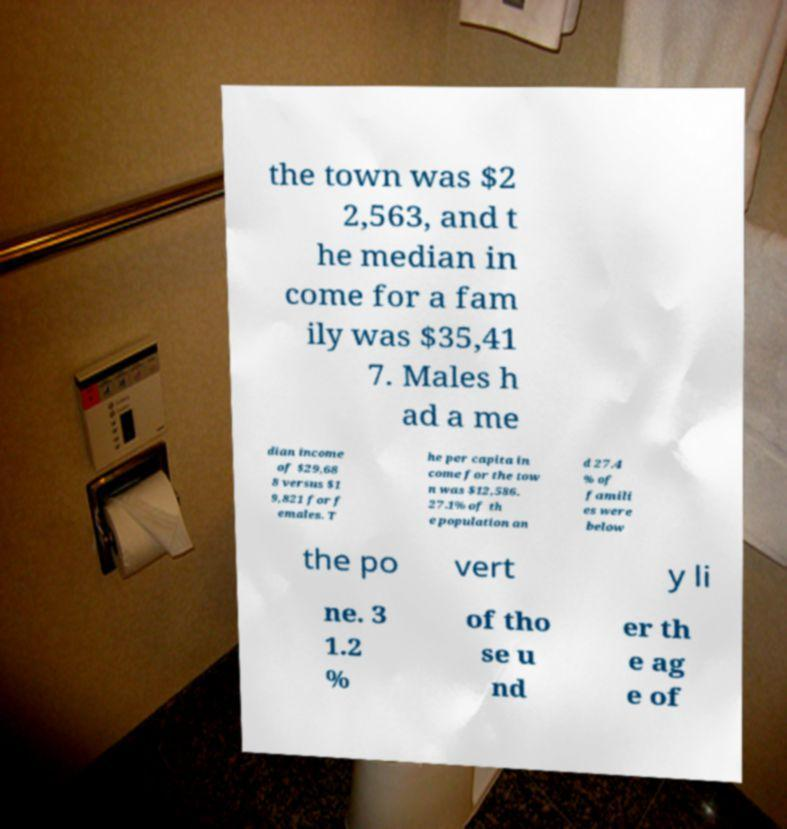Could you extract and type out the text from this image? the town was $2 2,563, and t he median in come for a fam ily was $35,41 7. Males h ad a me dian income of $29,68 8 versus $1 9,821 for f emales. T he per capita in come for the tow n was $12,586. 27.1% of th e population an d 27.4 % of famili es were below the po vert y li ne. 3 1.2 % of tho se u nd er th e ag e of 